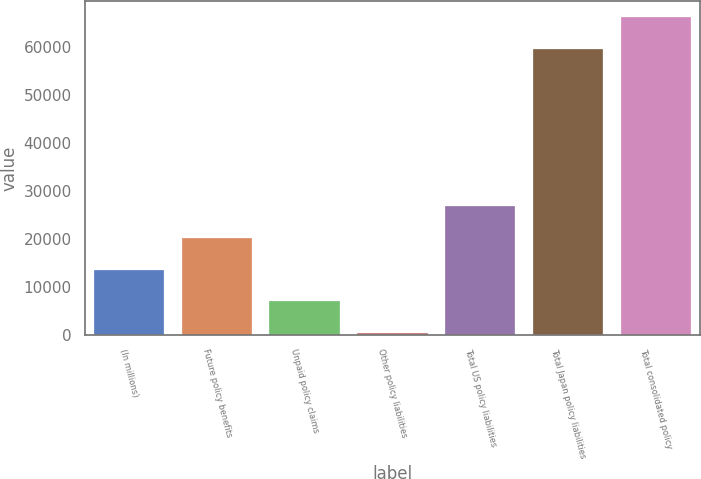<chart> <loc_0><loc_0><loc_500><loc_500><bar_chart><fcel>(In millions)<fcel>Future policy benefits<fcel>Unpaid policy claims<fcel>Other policy liabilities<fcel>Total US policy liabilities<fcel>Total Japan policy liabilities<fcel>Total consolidated policy<nl><fcel>13543.8<fcel>20128.2<fcel>6959.4<fcel>375<fcel>26712.6<fcel>59466<fcel>66219<nl></chart> 